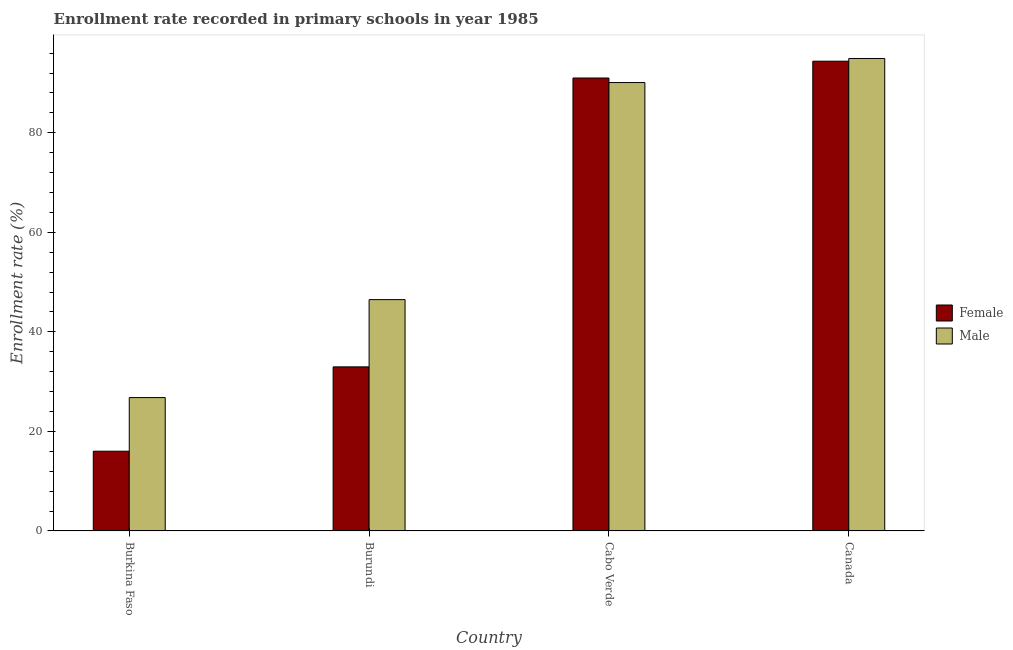How many bars are there on the 4th tick from the left?
Offer a very short reply. 2. How many bars are there on the 4th tick from the right?
Give a very brief answer. 2. What is the label of the 3rd group of bars from the left?
Offer a very short reply. Cabo Verde. In how many cases, is the number of bars for a given country not equal to the number of legend labels?
Make the answer very short. 0. What is the enrollment rate of female students in Burkina Faso?
Give a very brief answer. 16.02. Across all countries, what is the maximum enrollment rate of male students?
Keep it short and to the point. 94.93. Across all countries, what is the minimum enrollment rate of male students?
Keep it short and to the point. 26.8. In which country was the enrollment rate of female students maximum?
Provide a succinct answer. Canada. In which country was the enrollment rate of male students minimum?
Offer a terse response. Burkina Faso. What is the total enrollment rate of female students in the graph?
Your answer should be compact. 234.38. What is the difference between the enrollment rate of male students in Burkina Faso and that in Canada?
Give a very brief answer. -68.13. What is the difference between the enrollment rate of male students in Burkina Faso and the enrollment rate of female students in Cabo Verde?
Give a very brief answer. -64.21. What is the average enrollment rate of male students per country?
Offer a very short reply. 64.57. What is the difference between the enrollment rate of male students and enrollment rate of female students in Canada?
Your answer should be compact. 0.54. What is the ratio of the enrollment rate of female students in Cabo Verde to that in Canada?
Ensure brevity in your answer.  0.96. Is the enrollment rate of female students in Burkina Faso less than that in Cabo Verde?
Ensure brevity in your answer.  Yes. Is the difference between the enrollment rate of male students in Burkina Faso and Burundi greater than the difference between the enrollment rate of female students in Burkina Faso and Burundi?
Offer a very short reply. No. What is the difference between the highest and the second highest enrollment rate of female students?
Provide a short and direct response. 3.38. What is the difference between the highest and the lowest enrollment rate of female students?
Your answer should be very brief. 78.36. In how many countries, is the enrollment rate of male students greater than the average enrollment rate of male students taken over all countries?
Offer a terse response. 2. Is the sum of the enrollment rate of female students in Burundi and Canada greater than the maximum enrollment rate of male students across all countries?
Your response must be concise. Yes. What does the 2nd bar from the right in Canada represents?
Your response must be concise. Female. How many bars are there?
Provide a short and direct response. 8. Does the graph contain any zero values?
Offer a terse response. No. How many legend labels are there?
Give a very brief answer. 2. How are the legend labels stacked?
Offer a very short reply. Vertical. What is the title of the graph?
Give a very brief answer. Enrollment rate recorded in primary schools in year 1985. What is the label or title of the X-axis?
Your answer should be compact. Country. What is the label or title of the Y-axis?
Ensure brevity in your answer.  Enrollment rate (%). What is the Enrollment rate (%) of Female in Burkina Faso?
Provide a succinct answer. 16.02. What is the Enrollment rate (%) in Male in Burkina Faso?
Your answer should be compact. 26.8. What is the Enrollment rate (%) in Female in Burundi?
Give a very brief answer. 32.97. What is the Enrollment rate (%) of Male in Burundi?
Ensure brevity in your answer.  46.48. What is the Enrollment rate (%) in Female in Cabo Verde?
Your response must be concise. 91.01. What is the Enrollment rate (%) in Male in Cabo Verde?
Keep it short and to the point. 90.09. What is the Enrollment rate (%) of Female in Canada?
Offer a very short reply. 94.39. What is the Enrollment rate (%) of Male in Canada?
Your answer should be compact. 94.93. Across all countries, what is the maximum Enrollment rate (%) of Female?
Keep it short and to the point. 94.39. Across all countries, what is the maximum Enrollment rate (%) of Male?
Your answer should be compact. 94.93. Across all countries, what is the minimum Enrollment rate (%) in Female?
Your response must be concise. 16.02. Across all countries, what is the minimum Enrollment rate (%) of Male?
Ensure brevity in your answer.  26.8. What is the total Enrollment rate (%) in Female in the graph?
Make the answer very short. 234.38. What is the total Enrollment rate (%) of Male in the graph?
Provide a short and direct response. 258.3. What is the difference between the Enrollment rate (%) in Female in Burkina Faso and that in Burundi?
Provide a short and direct response. -16.95. What is the difference between the Enrollment rate (%) of Male in Burkina Faso and that in Burundi?
Give a very brief answer. -19.68. What is the difference between the Enrollment rate (%) of Female in Burkina Faso and that in Cabo Verde?
Ensure brevity in your answer.  -74.99. What is the difference between the Enrollment rate (%) in Male in Burkina Faso and that in Cabo Verde?
Your answer should be compact. -63.3. What is the difference between the Enrollment rate (%) of Female in Burkina Faso and that in Canada?
Your answer should be very brief. -78.36. What is the difference between the Enrollment rate (%) of Male in Burkina Faso and that in Canada?
Provide a succinct answer. -68.13. What is the difference between the Enrollment rate (%) in Female in Burundi and that in Cabo Verde?
Provide a short and direct response. -58.04. What is the difference between the Enrollment rate (%) in Male in Burundi and that in Cabo Verde?
Your answer should be compact. -43.61. What is the difference between the Enrollment rate (%) in Female in Burundi and that in Canada?
Your answer should be compact. -61.42. What is the difference between the Enrollment rate (%) in Male in Burundi and that in Canada?
Your response must be concise. -48.45. What is the difference between the Enrollment rate (%) of Female in Cabo Verde and that in Canada?
Offer a very short reply. -3.38. What is the difference between the Enrollment rate (%) in Male in Cabo Verde and that in Canada?
Offer a very short reply. -4.83. What is the difference between the Enrollment rate (%) of Female in Burkina Faso and the Enrollment rate (%) of Male in Burundi?
Offer a terse response. -30.46. What is the difference between the Enrollment rate (%) of Female in Burkina Faso and the Enrollment rate (%) of Male in Cabo Verde?
Provide a succinct answer. -74.07. What is the difference between the Enrollment rate (%) of Female in Burkina Faso and the Enrollment rate (%) of Male in Canada?
Ensure brevity in your answer.  -78.91. What is the difference between the Enrollment rate (%) of Female in Burundi and the Enrollment rate (%) of Male in Cabo Verde?
Give a very brief answer. -57.13. What is the difference between the Enrollment rate (%) in Female in Burundi and the Enrollment rate (%) in Male in Canada?
Provide a succinct answer. -61.96. What is the difference between the Enrollment rate (%) in Female in Cabo Verde and the Enrollment rate (%) in Male in Canada?
Your response must be concise. -3.92. What is the average Enrollment rate (%) of Female per country?
Keep it short and to the point. 58.59. What is the average Enrollment rate (%) in Male per country?
Provide a short and direct response. 64.57. What is the difference between the Enrollment rate (%) of Female and Enrollment rate (%) of Male in Burkina Faso?
Offer a very short reply. -10.78. What is the difference between the Enrollment rate (%) of Female and Enrollment rate (%) of Male in Burundi?
Provide a short and direct response. -13.51. What is the difference between the Enrollment rate (%) in Female and Enrollment rate (%) in Male in Cabo Verde?
Ensure brevity in your answer.  0.91. What is the difference between the Enrollment rate (%) of Female and Enrollment rate (%) of Male in Canada?
Make the answer very short. -0.54. What is the ratio of the Enrollment rate (%) of Female in Burkina Faso to that in Burundi?
Offer a very short reply. 0.49. What is the ratio of the Enrollment rate (%) of Male in Burkina Faso to that in Burundi?
Make the answer very short. 0.58. What is the ratio of the Enrollment rate (%) in Female in Burkina Faso to that in Cabo Verde?
Provide a succinct answer. 0.18. What is the ratio of the Enrollment rate (%) in Male in Burkina Faso to that in Cabo Verde?
Your answer should be very brief. 0.3. What is the ratio of the Enrollment rate (%) of Female in Burkina Faso to that in Canada?
Your response must be concise. 0.17. What is the ratio of the Enrollment rate (%) in Male in Burkina Faso to that in Canada?
Your response must be concise. 0.28. What is the ratio of the Enrollment rate (%) of Female in Burundi to that in Cabo Verde?
Your answer should be very brief. 0.36. What is the ratio of the Enrollment rate (%) of Male in Burundi to that in Cabo Verde?
Make the answer very short. 0.52. What is the ratio of the Enrollment rate (%) of Female in Burundi to that in Canada?
Your response must be concise. 0.35. What is the ratio of the Enrollment rate (%) in Male in Burundi to that in Canada?
Make the answer very short. 0.49. What is the ratio of the Enrollment rate (%) of Female in Cabo Verde to that in Canada?
Provide a succinct answer. 0.96. What is the ratio of the Enrollment rate (%) in Male in Cabo Verde to that in Canada?
Offer a very short reply. 0.95. What is the difference between the highest and the second highest Enrollment rate (%) in Female?
Ensure brevity in your answer.  3.38. What is the difference between the highest and the second highest Enrollment rate (%) in Male?
Your answer should be compact. 4.83. What is the difference between the highest and the lowest Enrollment rate (%) of Female?
Make the answer very short. 78.36. What is the difference between the highest and the lowest Enrollment rate (%) in Male?
Make the answer very short. 68.13. 